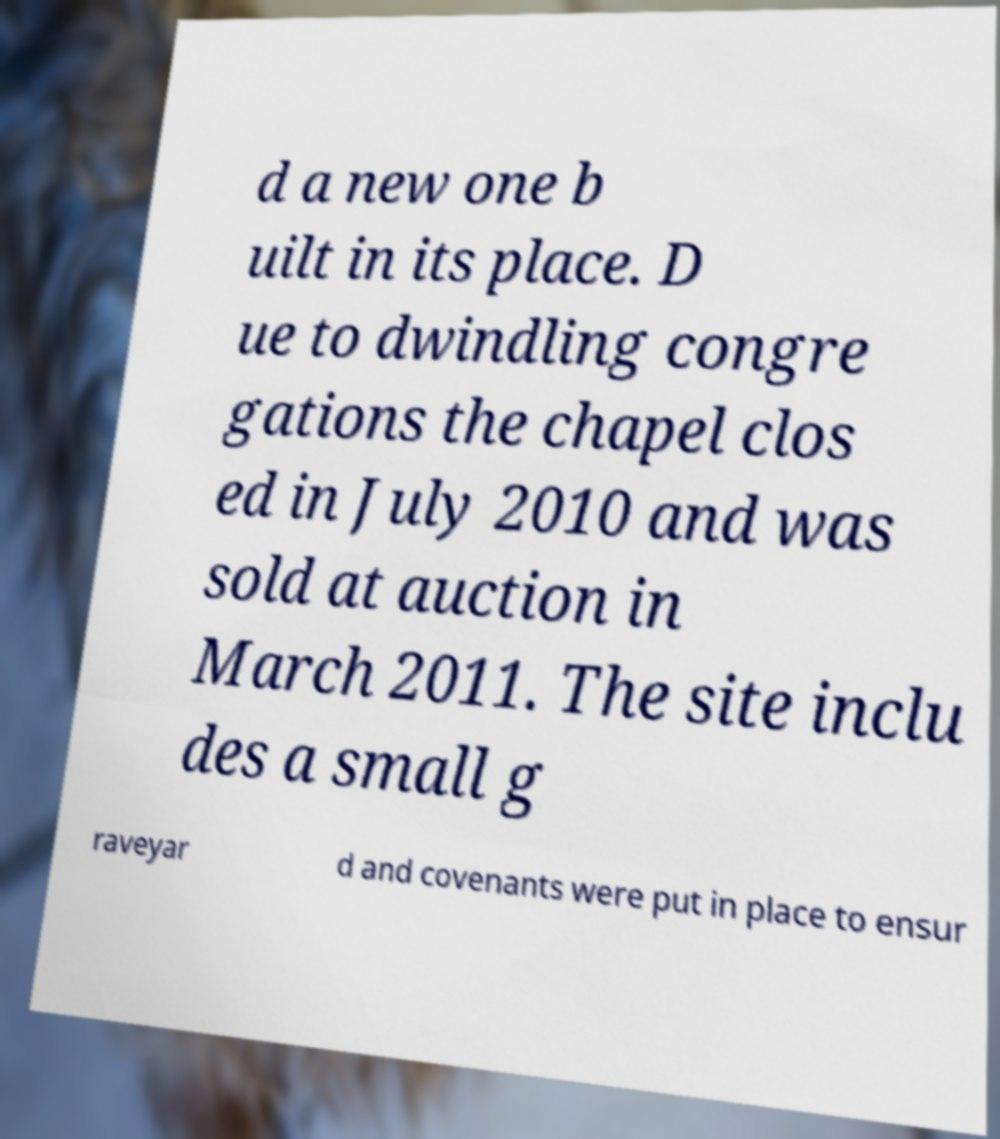For documentation purposes, I need the text within this image transcribed. Could you provide that? d a new one b uilt in its place. D ue to dwindling congre gations the chapel clos ed in July 2010 and was sold at auction in March 2011. The site inclu des a small g raveyar d and covenants were put in place to ensur 